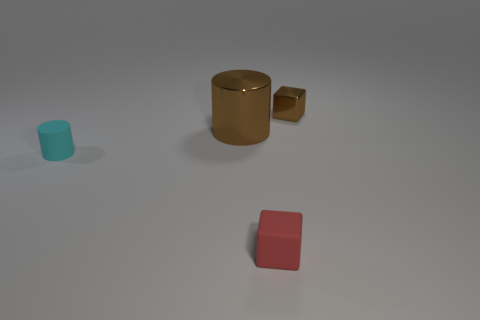There is a large metal thing that is the same color as the shiny block; what is its shape?
Give a very brief answer. Cylinder. Are there any other things of the same color as the large shiny cylinder?
Offer a terse response. Yes. The big brown object has what shape?
Provide a short and direct response. Cylinder. Does the small thing on the right side of the small red rubber block have the same shape as the tiny rubber thing that is behind the small matte block?
Give a very brief answer. No. The metal thing that is the same size as the red block is what shape?
Give a very brief answer. Cube. The thing that is made of the same material as the large cylinder is what color?
Make the answer very short. Brown. There is a red object; is its shape the same as the small object that is to the right of the red block?
Keep it short and to the point. Yes. What material is the small thing that is the same color as the big cylinder?
Your response must be concise. Metal. There is another red cube that is the same size as the metal cube; what is its material?
Ensure brevity in your answer.  Rubber. Are there any blocks that have the same color as the big shiny object?
Provide a succinct answer. Yes. 